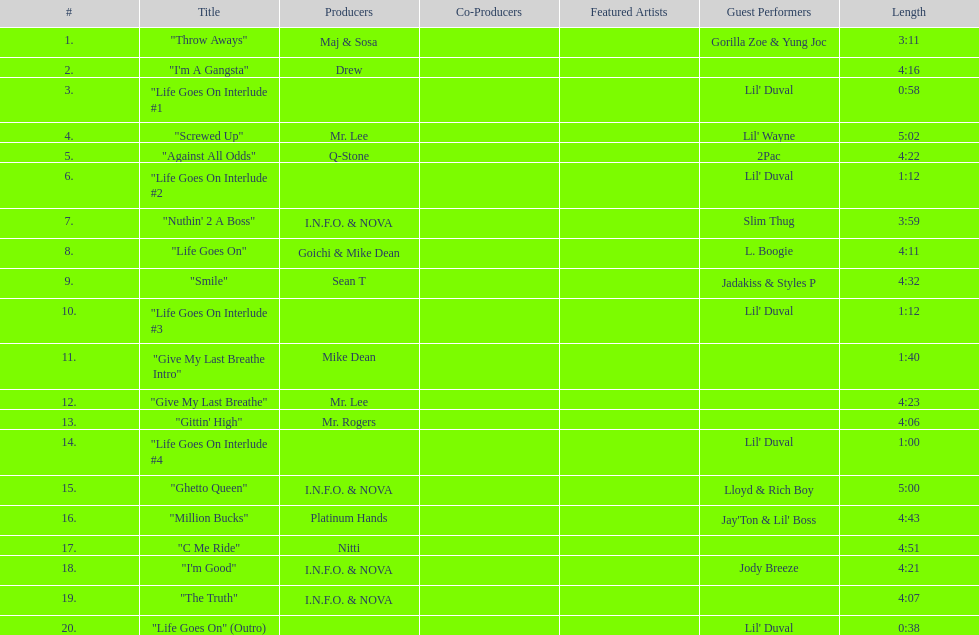What is the longest track on the album? "Screwed Up". 